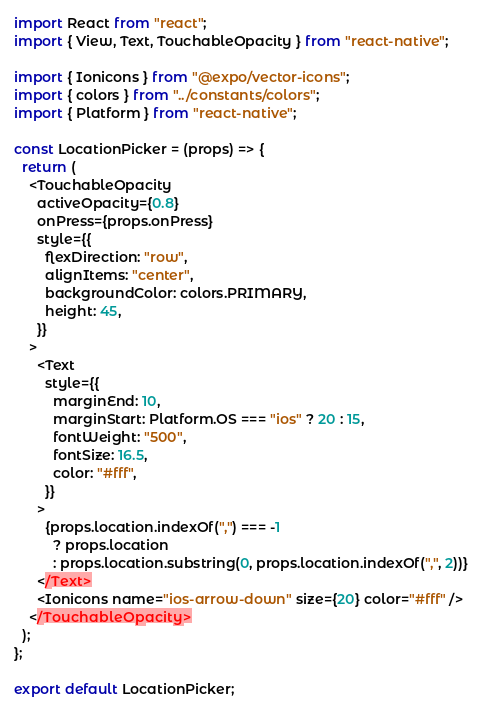<code> <loc_0><loc_0><loc_500><loc_500><_JavaScript_>import React from "react";
import { View, Text, TouchableOpacity } from "react-native";

import { Ionicons } from "@expo/vector-icons";
import { colors } from "../constants/colors";
import { Platform } from "react-native";

const LocationPicker = (props) => {
  return (
    <TouchableOpacity
      activeOpacity={0.8}
      onPress={props.onPress}
      style={{
        flexDirection: "row",
        alignItems: "center",
        backgroundColor: colors.PRIMARY,
        height: 45,
      }}
    >
      <Text
        style={{
          marginEnd: 10,
          marginStart: Platform.OS === "ios" ? 20 : 15,
          fontWeight: "500",
          fontSize: 16.5,
          color: "#fff",
        }}
      >
        {props.location.indexOf(",") === -1
          ? props.location
          : props.location.substring(0, props.location.indexOf(",", 2))}
      </Text>
      <Ionicons name="ios-arrow-down" size={20} color="#fff" />
    </TouchableOpacity>
  );
};

export default LocationPicker;
</code> 